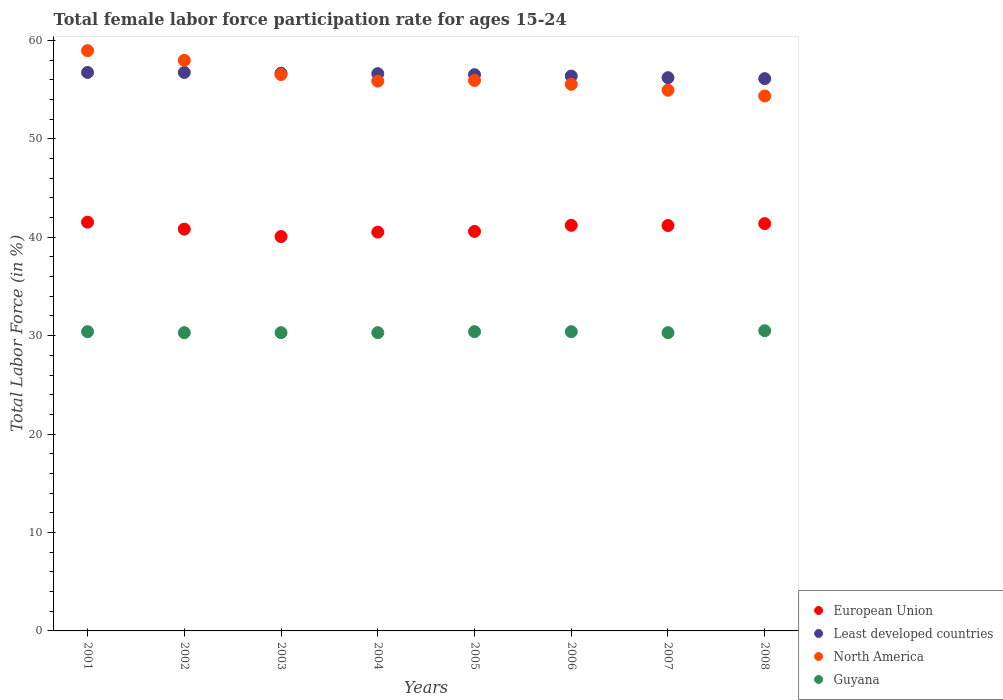How many different coloured dotlines are there?
Offer a terse response. 4. What is the female labor force participation rate in European Union in 2002?
Give a very brief answer. 40.82. Across all years, what is the maximum female labor force participation rate in North America?
Your response must be concise. 58.95. Across all years, what is the minimum female labor force participation rate in Least developed countries?
Keep it short and to the point. 56.11. In which year was the female labor force participation rate in Guyana maximum?
Your response must be concise. 2008. What is the total female labor force participation rate in Guyana in the graph?
Ensure brevity in your answer.  242.9. What is the difference between the female labor force participation rate in Guyana in 2001 and that in 2004?
Your answer should be compact. 0.1. What is the difference between the female labor force participation rate in European Union in 2006 and the female labor force participation rate in North America in 2005?
Provide a short and direct response. -14.72. What is the average female labor force participation rate in Least developed countries per year?
Keep it short and to the point. 56.49. In the year 2002, what is the difference between the female labor force participation rate in North America and female labor force participation rate in European Union?
Offer a terse response. 17.14. What is the ratio of the female labor force participation rate in European Union in 2003 to that in 2005?
Provide a short and direct response. 0.99. Is the difference between the female labor force participation rate in North America in 2001 and 2005 greater than the difference between the female labor force participation rate in European Union in 2001 and 2005?
Provide a succinct answer. Yes. What is the difference between the highest and the second highest female labor force participation rate in North America?
Make the answer very short. 0.99. What is the difference between the highest and the lowest female labor force participation rate in European Union?
Offer a very short reply. 1.46. Is the sum of the female labor force participation rate in European Union in 2004 and 2005 greater than the maximum female labor force participation rate in Guyana across all years?
Provide a short and direct response. Yes. Is it the case that in every year, the sum of the female labor force participation rate in North America and female labor force participation rate in European Union  is greater than the female labor force participation rate in Guyana?
Provide a succinct answer. Yes. Does the female labor force participation rate in Guyana monotonically increase over the years?
Keep it short and to the point. No. How many dotlines are there?
Provide a short and direct response. 4. How many years are there in the graph?
Make the answer very short. 8. Are the values on the major ticks of Y-axis written in scientific E-notation?
Your answer should be compact. No. Does the graph contain any zero values?
Provide a succinct answer. No. Does the graph contain grids?
Keep it short and to the point. No. How many legend labels are there?
Ensure brevity in your answer.  4. How are the legend labels stacked?
Offer a terse response. Vertical. What is the title of the graph?
Your answer should be very brief. Total female labor force participation rate for ages 15-24. Does "Grenada" appear as one of the legend labels in the graph?
Give a very brief answer. No. What is the label or title of the X-axis?
Your response must be concise. Years. What is the Total Labor Force (in %) of European Union in 2001?
Your answer should be compact. 41.53. What is the Total Labor Force (in %) in Least developed countries in 2001?
Provide a short and direct response. 56.74. What is the Total Labor Force (in %) of North America in 2001?
Offer a very short reply. 58.95. What is the Total Labor Force (in %) of Guyana in 2001?
Provide a succinct answer. 30.4. What is the Total Labor Force (in %) of European Union in 2002?
Provide a succinct answer. 40.82. What is the Total Labor Force (in %) of Least developed countries in 2002?
Your answer should be compact. 56.74. What is the Total Labor Force (in %) in North America in 2002?
Make the answer very short. 57.96. What is the Total Labor Force (in %) in Guyana in 2002?
Offer a terse response. 30.3. What is the Total Labor Force (in %) of European Union in 2003?
Offer a terse response. 40.07. What is the Total Labor Force (in %) of Least developed countries in 2003?
Give a very brief answer. 56.67. What is the Total Labor Force (in %) of North America in 2003?
Ensure brevity in your answer.  56.53. What is the Total Labor Force (in %) of Guyana in 2003?
Provide a short and direct response. 30.3. What is the Total Labor Force (in %) in European Union in 2004?
Your answer should be very brief. 40.51. What is the Total Labor Force (in %) of Least developed countries in 2004?
Your response must be concise. 56.61. What is the Total Labor Force (in %) in North America in 2004?
Provide a short and direct response. 55.85. What is the Total Labor Force (in %) in Guyana in 2004?
Your answer should be compact. 30.3. What is the Total Labor Force (in %) of European Union in 2005?
Provide a succinct answer. 40.59. What is the Total Labor Force (in %) of Least developed countries in 2005?
Ensure brevity in your answer.  56.51. What is the Total Labor Force (in %) in North America in 2005?
Your answer should be compact. 55.92. What is the Total Labor Force (in %) of Guyana in 2005?
Give a very brief answer. 30.4. What is the Total Labor Force (in %) of European Union in 2006?
Your response must be concise. 41.2. What is the Total Labor Force (in %) in Least developed countries in 2006?
Your answer should be very brief. 56.37. What is the Total Labor Force (in %) in North America in 2006?
Give a very brief answer. 55.53. What is the Total Labor Force (in %) of Guyana in 2006?
Your answer should be very brief. 30.4. What is the Total Labor Force (in %) in European Union in 2007?
Your answer should be very brief. 41.19. What is the Total Labor Force (in %) in Least developed countries in 2007?
Keep it short and to the point. 56.21. What is the Total Labor Force (in %) in North America in 2007?
Give a very brief answer. 54.93. What is the Total Labor Force (in %) of Guyana in 2007?
Offer a very short reply. 30.3. What is the Total Labor Force (in %) of European Union in 2008?
Ensure brevity in your answer.  41.38. What is the Total Labor Force (in %) of Least developed countries in 2008?
Offer a terse response. 56.11. What is the Total Labor Force (in %) in North America in 2008?
Make the answer very short. 54.35. What is the Total Labor Force (in %) in Guyana in 2008?
Ensure brevity in your answer.  30.5. Across all years, what is the maximum Total Labor Force (in %) of European Union?
Your response must be concise. 41.53. Across all years, what is the maximum Total Labor Force (in %) of Least developed countries?
Provide a short and direct response. 56.74. Across all years, what is the maximum Total Labor Force (in %) of North America?
Provide a succinct answer. 58.95. Across all years, what is the maximum Total Labor Force (in %) in Guyana?
Your response must be concise. 30.5. Across all years, what is the minimum Total Labor Force (in %) of European Union?
Keep it short and to the point. 40.07. Across all years, what is the minimum Total Labor Force (in %) in Least developed countries?
Give a very brief answer. 56.11. Across all years, what is the minimum Total Labor Force (in %) of North America?
Offer a terse response. 54.35. Across all years, what is the minimum Total Labor Force (in %) in Guyana?
Your response must be concise. 30.3. What is the total Total Labor Force (in %) in European Union in the graph?
Provide a short and direct response. 327.29. What is the total Total Labor Force (in %) of Least developed countries in the graph?
Your response must be concise. 451.95. What is the total Total Labor Force (in %) of North America in the graph?
Give a very brief answer. 450.03. What is the total Total Labor Force (in %) in Guyana in the graph?
Offer a terse response. 242.9. What is the difference between the Total Labor Force (in %) in European Union in 2001 and that in 2002?
Provide a short and direct response. 0.71. What is the difference between the Total Labor Force (in %) in Least developed countries in 2001 and that in 2002?
Ensure brevity in your answer.  0. What is the difference between the Total Labor Force (in %) of North America in 2001 and that in 2002?
Keep it short and to the point. 0.99. What is the difference between the Total Labor Force (in %) of Guyana in 2001 and that in 2002?
Give a very brief answer. 0.1. What is the difference between the Total Labor Force (in %) in European Union in 2001 and that in 2003?
Make the answer very short. 1.46. What is the difference between the Total Labor Force (in %) of Least developed countries in 2001 and that in 2003?
Provide a succinct answer. 0.07. What is the difference between the Total Labor Force (in %) in North America in 2001 and that in 2003?
Keep it short and to the point. 2.42. What is the difference between the Total Labor Force (in %) in European Union in 2001 and that in 2004?
Provide a succinct answer. 1.01. What is the difference between the Total Labor Force (in %) of Least developed countries in 2001 and that in 2004?
Make the answer very short. 0.12. What is the difference between the Total Labor Force (in %) in North America in 2001 and that in 2004?
Your answer should be very brief. 3.1. What is the difference between the Total Labor Force (in %) in European Union in 2001 and that in 2005?
Make the answer very short. 0.94. What is the difference between the Total Labor Force (in %) in Least developed countries in 2001 and that in 2005?
Your answer should be very brief. 0.23. What is the difference between the Total Labor Force (in %) in North America in 2001 and that in 2005?
Your response must be concise. 3.03. What is the difference between the Total Labor Force (in %) in European Union in 2001 and that in 2006?
Provide a succinct answer. 0.32. What is the difference between the Total Labor Force (in %) in Least developed countries in 2001 and that in 2006?
Make the answer very short. 0.37. What is the difference between the Total Labor Force (in %) of North America in 2001 and that in 2006?
Offer a very short reply. 3.42. What is the difference between the Total Labor Force (in %) in European Union in 2001 and that in 2007?
Keep it short and to the point. 0.34. What is the difference between the Total Labor Force (in %) of Least developed countries in 2001 and that in 2007?
Provide a short and direct response. 0.53. What is the difference between the Total Labor Force (in %) in North America in 2001 and that in 2007?
Keep it short and to the point. 4.02. What is the difference between the Total Labor Force (in %) in European Union in 2001 and that in 2008?
Provide a short and direct response. 0.15. What is the difference between the Total Labor Force (in %) of Least developed countries in 2001 and that in 2008?
Make the answer very short. 0.63. What is the difference between the Total Labor Force (in %) of North America in 2001 and that in 2008?
Provide a short and direct response. 4.6. What is the difference between the Total Labor Force (in %) in Guyana in 2001 and that in 2008?
Give a very brief answer. -0.1. What is the difference between the Total Labor Force (in %) in European Union in 2002 and that in 2003?
Your answer should be compact. 0.75. What is the difference between the Total Labor Force (in %) in Least developed countries in 2002 and that in 2003?
Ensure brevity in your answer.  0.07. What is the difference between the Total Labor Force (in %) in North America in 2002 and that in 2003?
Keep it short and to the point. 1.43. What is the difference between the Total Labor Force (in %) in European Union in 2002 and that in 2004?
Provide a short and direct response. 0.3. What is the difference between the Total Labor Force (in %) of Least developed countries in 2002 and that in 2004?
Make the answer very short. 0.12. What is the difference between the Total Labor Force (in %) in North America in 2002 and that in 2004?
Provide a short and direct response. 2.11. What is the difference between the Total Labor Force (in %) in Guyana in 2002 and that in 2004?
Provide a succinct answer. 0. What is the difference between the Total Labor Force (in %) in European Union in 2002 and that in 2005?
Offer a very short reply. 0.23. What is the difference between the Total Labor Force (in %) in Least developed countries in 2002 and that in 2005?
Your answer should be very brief. 0.23. What is the difference between the Total Labor Force (in %) in North America in 2002 and that in 2005?
Ensure brevity in your answer.  2.04. What is the difference between the Total Labor Force (in %) in European Union in 2002 and that in 2006?
Keep it short and to the point. -0.38. What is the difference between the Total Labor Force (in %) in Least developed countries in 2002 and that in 2006?
Offer a terse response. 0.37. What is the difference between the Total Labor Force (in %) in North America in 2002 and that in 2006?
Provide a short and direct response. 2.43. What is the difference between the Total Labor Force (in %) of European Union in 2002 and that in 2007?
Offer a terse response. -0.37. What is the difference between the Total Labor Force (in %) of Least developed countries in 2002 and that in 2007?
Your response must be concise. 0.53. What is the difference between the Total Labor Force (in %) in North America in 2002 and that in 2007?
Your response must be concise. 3.03. What is the difference between the Total Labor Force (in %) in Guyana in 2002 and that in 2007?
Give a very brief answer. 0. What is the difference between the Total Labor Force (in %) in European Union in 2002 and that in 2008?
Your answer should be compact. -0.56. What is the difference between the Total Labor Force (in %) of Least developed countries in 2002 and that in 2008?
Keep it short and to the point. 0.63. What is the difference between the Total Labor Force (in %) in North America in 2002 and that in 2008?
Your answer should be very brief. 3.61. What is the difference between the Total Labor Force (in %) of European Union in 2003 and that in 2004?
Your response must be concise. -0.45. What is the difference between the Total Labor Force (in %) of Least developed countries in 2003 and that in 2004?
Provide a short and direct response. 0.05. What is the difference between the Total Labor Force (in %) of North America in 2003 and that in 2004?
Offer a very short reply. 0.67. What is the difference between the Total Labor Force (in %) of Guyana in 2003 and that in 2004?
Your response must be concise. 0. What is the difference between the Total Labor Force (in %) in European Union in 2003 and that in 2005?
Make the answer very short. -0.52. What is the difference between the Total Labor Force (in %) in Least developed countries in 2003 and that in 2005?
Offer a very short reply. 0.15. What is the difference between the Total Labor Force (in %) in North America in 2003 and that in 2005?
Give a very brief answer. 0.6. What is the difference between the Total Labor Force (in %) of Guyana in 2003 and that in 2005?
Give a very brief answer. -0.1. What is the difference between the Total Labor Force (in %) of European Union in 2003 and that in 2006?
Provide a short and direct response. -1.14. What is the difference between the Total Labor Force (in %) of Least developed countries in 2003 and that in 2006?
Provide a short and direct response. 0.29. What is the difference between the Total Labor Force (in %) of North America in 2003 and that in 2006?
Give a very brief answer. 1. What is the difference between the Total Labor Force (in %) in European Union in 2003 and that in 2007?
Your response must be concise. -1.12. What is the difference between the Total Labor Force (in %) of Least developed countries in 2003 and that in 2007?
Ensure brevity in your answer.  0.46. What is the difference between the Total Labor Force (in %) of North America in 2003 and that in 2007?
Offer a terse response. 1.6. What is the difference between the Total Labor Force (in %) of Guyana in 2003 and that in 2007?
Your response must be concise. 0. What is the difference between the Total Labor Force (in %) of European Union in 2003 and that in 2008?
Your response must be concise. -1.31. What is the difference between the Total Labor Force (in %) of Least developed countries in 2003 and that in 2008?
Keep it short and to the point. 0.56. What is the difference between the Total Labor Force (in %) of North America in 2003 and that in 2008?
Provide a short and direct response. 2.18. What is the difference between the Total Labor Force (in %) in Guyana in 2003 and that in 2008?
Offer a terse response. -0.2. What is the difference between the Total Labor Force (in %) in European Union in 2004 and that in 2005?
Your answer should be very brief. -0.07. What is the difference between the Total Labor Force (in %) in Least developed countries in 2004 and that in 2005?
Provide a succinct answer. 0.1. What is the difference between the Total Labor Force (in %) of North America in 2004 and that in 2005?
Your answer should be very brief. -0.07. What is the difference between the Total Labor Force (in %) in Guyana in 2004 and that in 2005?
Give a very brief answer. -0.1. What is the difference between the Total Labor Force (in %) in European Union in 2004 and that in 2006?
Give a very brief answer. -0.69. What is the difference between the Total Labor Force (in %) of Least developed countries in 2004 and that in 2006?
Offer a terse response. 0.24. What is the difference between the Total Labor Force (in %) of North America in 2004 and that in 2006?
Ensure brevity in your answer.  0.32. What is the difference between the Total Labor Force (in %) in European Union in 2004 and that in 2007?
Offer a terse response. -0.67. What is the difference between the Total Labor Force (in %) of Least developed countries in 2004 and that in 2007?
Your response must be concise. 0.41. What is the difference between the Total Labor Force (in %) of North America in 2004 and that in 2007?
Offer a terse response. 0.92. What is the difference between the Total Labor Force (in %) in Guyana in 2004 and that in 2007?
Your answer should be very brief. 0. What is the difference between the Total Labor Force (in %) in European Union in 2004 and that in 2008?
Offer a terse response. -0.87. What is the difference between the Total Labor Force (in %) in Least developed countries in 2004 and that in 2008?
Provide a short and direct response. 0.51. What is the difference between the Total Labor Force (in %) of North America in 2004 and that in 2008?
Ensure brevity in your answer.  1.51. What is the difference between the Total Labor Force (in %) of European Union in 2005 and that in 2006?
Make the answer very short. -0.62. What is the difference between the Total Labor Force (in %) of Least developed countries in 2005 and that in 2006?
Your answer should be compact. 0.14. What is the difference between the Total Labor Force (in %) in North America in 2005 and that in 2006?
Your response must be concise. 0.39. What is the difference between the Total Labor Force (in %) of European Union in 2005 and that in 2007?
Offer a terse response. -0.6. What is the difference between the Total Labor Force (in %) in Least developed countries in 2005 and that in 2007?
Offer a very short reply. 0.31. What is the difference between the Total Labor Force (in %) in North America in 2005 and that in 2007?
Offer a terse response. 0.99. What is the difference between the Total Labor Force (in %) in European Union in 2005 and that in 2008?
Offer a terse response. -0.79. What is the difference between the Total Labor Force (in %) in Least developed countries in 2005 and that in 2008?
Give a very brief answer. 0.4. What is the difference between the Total Labor Force (in %) in North America in 2005 and that in 2008?
Your answer should be very brief. 1.57. What is the difference between the Total Labor Force (in %) in Guyana in 2005 and that in 2008?
Provide a short and direct response. -0.1. What is the difference between the Total Labor Force (in %) in European Union in 2006 and that in 2007?
Your answer should be very brief. 0.02. What is the difference between the Total Labor Force (in %) in Least developed countries in 2006 and that in 2007?
Offer a terse response. 0.17. What is the difference between the Total Labor Force (in %) of North America in 2006 and that in 2007?
Your answer should be very brief. 0.6. What is the difference between the Total Labor Force (in %) in Guyana in 2006 and that in 2007?
Offer a terse response. 0.1. What is the difference between the Total Labor Force (in %) in European Union in 2006 and that in 2008?
Keep it short and to the point. -0.18. What is the difference between the Total Labor Force (in %) in Least developed countries in 2006 and that in 2008?
Your answer should be compact. 0.26. What is the difference between the Total Labor Force (in %) in North America in 2006 and that in 2008?
Provide a succinct answer. 1.18. What is the difference between the Total Labor Force (in %) of European Union in 2007 and that in 2008?
Keep it short and to the point. -0.19. What is the difference between the Total Labor Force (in %) of Least developed countries in 2007 and that in 2008?
Offer a terse response. 0.1. What is the difference between the Total Labor Force (in %) of North America in 2007 and that in 2008?
Provide a succinct answer. 0.58. What is the difference between the Total Labor Force (in %) in Guyana in 2007 and that in 2008?
Your answer should be very brief. -0.2. What is the difference between the Total Labor Force (in %) of European Union in 2001 and the Total Labor Force (in %) of Least developed countries in 2002?
Give a very brief answer. -15.21. What is the difference between the Total Labor Force (in %) in European Union in 2001 and the Total Labor Force (in %) in North America in 2002?
Offer a terse response. -16.44. What is the difference between the Total Labor Force (in %) of European Union in 2001 and the Total Labor Force (in %) of Guyana in 2002?
Your response must be concise. 11.23. What is the difference between the Total Labor Force (in %) in Least developed countries in 2001 and the Total Labor Force (in %) in North America in 2002?
Offer a terse response. -1.23. What is the difference between the Total Labor Force (in %) of Least developed countries in 2001 and the Total Labor Force (in %) of Guyana in 2002?
Offer a very short reply. 26.44. What is the difference between the Total Labor Force (in %) of North America in 2001 and the Total Labor Force (in %) of Guyana in 2002?
Your answer should be very brief. 28.65. What is the difference between the Total Labor Force (in %) in European Union in 2001 and the Total Labor Force (in %) in Least developed countries in 2003?
Keep it short and to the point. -15.14. What is the difference between the Total Labor Force (in %) in European Union in 2001 and the Total Labor Force (in %) in North America in 2003?
Your response must be concise. -15. What is the difference between the Total Labor Force (in %) of European Union in 2001 and the Total Labor Force (in %) of Guyana in 2003?
Provide a succinct answer. 11.23. What is the difference between the Total Labor Force (in %) in Least developed countries in 2001 and the Total Labor Force (in %) in North America in 2003?
Make the answer very short. 0.21. What is the difference between the Total Labor Force (in %) of Least developed countries in 2001 and the Total Labor Force (in %) of Guyana in 2003?
Give a very brief answer. 26.44. What is the difference between the Total Labor Force (in %) in North America in 2001 and the Total Labor Force (in %) in Guyana in 2003?
Ensure brevity in your answer.  28.65. What is the difference between the Total Labor Force (in %) in European Union in 2001 and the Total Labor Force (in %) in Least developed countries in 2004?
Provide a short and direct response. -15.09. What is the difference between the Total Labor Force (in %) of European Union in 2001 and the Total Labor Force (in %) of North America in 2004?
Your response must be concise. -14.33. What is the difference between the Total Labor Force (in %) in European Union in 2001 and the Total Labor Force (in %) in Guyana in 2004?
Your answer should be compact. 11.23. What is the difference between the Total Labor Force (in %) in Least developed countries in 2001 and the Total Labor Force (in %) in North America in 2004?
Your response must be concise. 0.88. What is the difference between the Total Labor Force (in %) in Least developed countries in 2001 and the Total Labor Force (in %) in Guyana in 2004?
Your response must be concise. 26.44. What is the difference between the Total Labor Force (in %) of North America in 2001 and the Total Labor Force (in %) of Guyana in 2004?
Make the answer very short. 28.65. What is the difference between the Total Labor Force (in %) in European Union in 2001 and the Total Labor Force (in %) in Least developed countries in 2005?
Provide a succinct answer. -14.98. What is the difference between the Total Labor Force (in %) in European Union in 2001 and the Total Labor Force (in %) in North America in 2005?
Keep it short and to the point. -14.4. What is the difference between the Total Labor Force (in %) in European Union in 2001 and the Total Labor Force (in %) in Guyana in 2005?
Ensure brevity in your answer.  11.13. What is the difference between the Total Labor Force (in %) of Least developed countries in 2001 and the Total Labor Force (in %) of North America in 2005?
Your answer should be very brief. 0.81. What is the difference between the Total Labor Force (in %) in Least developed countries in 2001 and the Total Labor Force (in %) in Guyana in 2005?
Your answer should be very brief. 26.34. What is the difference between the Total Labor Force (in %) in North America in 2001 and the Total Labor Force (in %) in Guyana in 2005?
Offer a very short reply. 28.55. What is the difference between the Total Labor Force (in %) in European Union in 2001 and the Total Labor Force (in %) in Least developed countries in 2006?
Ensure brevity in your answer.  -14.84. What is the difference between the Total Labor Force (in %) of European Union in 2001 and the Total Labor Force (in %) of North America in 2006?
Provide a short and direct response. -14. What is the difference between the Total Labor Force (in %) in European Union in 2001 and the Total Labor Force (in %) in Guyana in 2006?
Provide a short and direct response. 11.13. What is the difference between the Total Labor Force (in %) of Least developed countries in 2001 and the Total Labor Force (in %) of North America in 2006?
Your response must be concise. 1.21. What is the difference between the Total Labor Force (in %) in Least developed countries in 2001 and the Total Labor Force (in %) in Guyana in 2006?
Your answer should be very brief. 26.34. What is the difference between the Total Labor Force (in %) in North America in 2001 and the Total Labor Force (in %) in Guyana in 2006?
Ensure brevity in your answer.  28.55. What is the difference between the Total Labor Force (in %) in European Union in 2001 and the Total Labor Force (in %) in Least developed countries in 2007?
Provide a succinct answer. -14.68. What is the difference between the Total Labor Force (in %) of European Union in 2001 and the Total Labor Force (in %) of North America in 2007?
Give a very brief answer. -13.4. What is the difference between the Total Labor Force (in %) in European Union in 2001 and the Total Labor Force (in %) in Guyana in 2007?
Give a very brief answer. 11.23. What is the difference between the Total Labor Force (in %) in Least developed countries in 2001 and the Total Labor Force (in %) in North America in 2007?
Keep it short and to the point. 1.81. What is the difference between the Total Labor Force (in %) in Least developed countries in 2001 and the Total Labor Force (in %) in Guyana in 2007?
Provide a succinct answer. 26.44. What is the difference between the Total Labor Force (in %) of North America in 2001 and the Total Labor Force (in %) of Guyana in 2007?
Offer a terse response. 28.65. What is the difference between the Total Labor Force (in %) in European Union in 2001 and the Total Labor Force (in %) in Least developed countries in 2008?
Keep it short and to the point. -14.58. What is the difference between the Total Labor Force (in %) of European Union in 2001 and the Total Labor Force (in %) of North America in 2008?
Keep it short and to the point. -12.82. What is the difference between the Total Labor Force (in %) in European Union in 2001 and the Total Labor Force (in %) in Guyana in 2008?
Your response must be concise. 11.03. What is the difference between the Total Labor Force (in %) of Least developed countries in 2001 and the Total Labor Force (in %) of North America in 2008?
Keep it short and to the point. 2.39. What is the difference between the Total Labor Force (in %) of Least developed countries in 2001 and the Total Labor Force (in %) of Guyana in 2008?
Offer a terse response. 26.24. What is the difference between the Total Labor Force (in %) of North America in 2001 and the Total Labor Force (in %) of Guyana in 2008?
Your answer should be very brief. 28.45. What is the difference between the Total Labor Force (in %) in European Union in 2002 and the Total Labor Force (in %) in Least developed countries in 2003?
Ensure brevity in your answer.  -15.85. What is the difference between the Total Labor Force (in %) in European Union in 2002 and the Total Labor Force (in %) in North America in 2003?
Offer a very short reply. -15.71. What is the difference between the Total Labor Force (in %) in European Union in 2002 and the Total Labor Force (in %) in Guyana in 2003?
Ensure brevity in your answer.  10.52. What is the difference between the Total Labor Force (in %) of Least developed countries in 2002 and the Total Labor Force (in %) of North America in 2003?
Keep it short and to the point. 0.21. What is the difference between the Total Labor Force (in %) in Least developed countries in 2002 and the Total Labor Force (in %) in Guyana in 2003?
Make the answer very short. 26.44. What is the difference between the Total Labor Force (in %) in North America in 2002 and the Total Labor Force (in %) in Guyana in 2003?
Ensure brevity in your answer.  27.66. What is the difference between the Total Labor Force (in %) of European Union in 2002 and the Total Labor Force (in %) of Least developed countries in 2004?
Make the answer very short. -15.8. What is the difference between the Total Labor Force (in %) of European Union in 2002 and the Total Labor Force (in %) of North America in 2004?
Your response must be concise. -15.04. What is the difference between the Total Labor Force (in %) of European Union in 2002 and the Total Labor Force (in %) of Guyana in 2004?
Your answer should be very brief. 10.52. What is the difference between the Total Labor Force (in %) in Least developed countries in 2002 and the Total Labor Force (in %) in North America in 2004?
Provide a short and direct response. 0.88. What is the difference between the Total Labor Force (in %) in Least developed countries in 2002 and the Total Labor Force (in %) in Guyana in 2004?
Your answer should be very brief. 26.44. What is the difference between the Total Labor Force (in %) in North America in 2002 and the Total Labor Force (in %) in Guyana in 2004?
Provide a succinct answer. 27.66. What is the difference between the Total Labor Force (in %) of European Union in 2002 and the Total Labor Force (in %) of Least developed countries in 2005?
Your answer should be compact. -15.69. What is the difference between the Total Labor Force (in %) of European Union in 2002 and the Total Labor Force (in %) of North America in 2005?
Your answer should be very brief. -15.11. What is the difference between the Total Labor Force (in %) of European Union in 2002 and the Total Labor Force (in %) of Guyana in 2005?
Offer a very short reply. 10.42. What is the difference between the Total Labor Force (in %) of Least developed countries in 2002 and the Total Labor Force (in %) of North America in 2005?
Ensure brevity in your answer.  0.81. What is the difference between the Total Labor Force (in %) of Least developed countries in 2002 and the Total Labor Force (in %) of Guyana in 2005?
Provide a succinct answer. 26.34. What is the difference between the Total Labor Force (in %) in North America in 2002 and the Total Labor Force (in %) in Guyana in 2005?
Provide a short and direct response. 27.56. What is the difference between the Total Labor Force (in %) of European Union in 2002 and the Total Labor Force (in %) of Least developed countries in 2006?
Offer a very short reply. -15.55. What is the difference between the Total Labor Force (in %) in European Union in 2002 and the Total Labor Force (in %) in North America in 2006?
Your answer should be very brief. -14.71. What is the difference between the Total Labor Force (in %) of European Union in 2002 and the Total Labor Force (in %) of Guyana in 2006?
Make the answer very short. 10.42. What is the difference between the Total Labor Force (in %) of Least developed countries in 2002 and the Total Labor Force (in %) of North America in 2006?
Provide a short and direct response. 1.21. What is the difference between the Total Labor Force (in %) in Least developed countries in 2002 and the Total Labor Force (in %) in Guyana in 2006?
Offer a very short reply. 26.34. What is the difference between the Total Labor Force (in %) of North America in 2002 and the Total Labor Force (in %) of Guyana in 2006?
Make the answer very short. 27.56. What is the difference between the Total Labor Force (in %) in European Union in 2002 and the Total Labor Force (in %) in Least developed countries in 2007?
Your answer should be very brief. -15.39. What is the difference between the Total Labor Force (in %) in European Union in 2002 and the Total Labor Force (in %) in North America in 2007?
Your response must be concise. -14.11. What is the difference between the Total Labor Force (in %) of European Union in 2002 and the Total Labor Force (in %) of Guyana in 2007?
Offer a very short reply. 10.52. What is the difference between the Total Labor Force (in %) of Least developed countries in 2002 and the Total Labor Force (in %) of North America in 2007?
Give a very brief answer. 1.81. What is the difference between the Total Labor Force (in %) of Least developed countries in 2002 and the Total Labor Force (in %) of Guyana in 2007?
Offer a terse response. 26.44. What is the difference between the Total Labor Force (in %) in North America in 2002 and the Total Labor Force (in %) in Guyana in 2007?
Keep it short and to the point. 27.66. What is the difference between the Total Labor Force (in %) of European Union in 2002 and the Total Labor Force (in %) of Least developed countries in 2008?
Give a very brief answer. -15.29. What is the difference between the Total Labor Force (in %) of European Union in 2002 and the Total Labor Force (in %) of North America in 2008?
Keep it short and to the point. -13.53. What is the difference between the Total Labor Force (in %) in European Union in 2002 and the Total Labor Force (in %) in Guyana in 2008?
Your answer should be compact. 10.32. What is the difference between the Total Labor Force (in %) in Least developed countries in 2002 and the Total Labor Force (in %) in North America in 2008?
Give a very brief answer. 2.39. What is the difference between the Total Labor Force (in %) in Least developed countries in 2002 and the Total Labor Force (in %) in Guyana in 2008?
Offer a very short reply. 26.24. What is the difference between the Total Labor Force (in %) of North America in 2002 and the Total Labor Force (in %) of Guyana in 2008?
Your answer should be very brief. 27.46. What is the difference between the Total Labor Force (in %) of European Union in 2003 and the Total Labor Force (in %) of Least developed countries in 2004?
Provide a short and direct response. -16.55. What is the difference between the Total Labor Force (in %) of European Union in 2003 and the Total Labor Force (in %) of North America in 2004?
Offer a very short reply. -15.79. What is the difference between the Total Labor Force (in %) of European Union in 2003 and the Total Labor Force (in %) of Guyana in 2004?
Give a very brief answer. 9.77. What is the difference between the Total Labor Force (in %) in Least developed countries in 2003 and the Total Labor Force (in %) in North America in 2004?
Provide a succinct answer. 0.81. What is the difference between the Total Labor Force (in %) in Least developed countries in 2003 and the Total Labor Force (in %) in Guyana in 2004?
Give a very brief answer. 26.37. What is the difference between the Total Labor Force (in %) in North America in 2003 and the Total Labor Force (in %) in Guyana in 2004?
Your answer should be very brief. 26.23. What is the difference between the Total Labor Force (in %) in European Union in 2003 and the Total Labor Force (in %) in Least developed countries in 2005?
Provide a succinct answer. -16.44. What is the difference between the Total Labor Force (in %) in European Union in 2003 and the Total Labor Force (in %) in North America in 2005?
Offer a very short reply. -15.86. What is the difference between the Total Labor Force (in %) in European Union in 2003 and the Total Labor Force (in %) in Guyana in 2005?
Your response must be concise. 9.67. What is the difference between the Total Labor Force (in %) of Least developed countries in 2003 and the Total Labor Force (in %) of North America in 2005?
Make the answer very short. 0.74. What is the difference between the Total Labor Force (in %) in Least developed countries in 2003 and the Total Labor Force (in %) in Guyana in 2005?
Your answer should be very brief. 26.27. What is the difference between the Total Labor Force (in %) in North America in 2003 and the Total Labor Force (in %) in Guyana in 2005?
Provide a succinct answer. 26.13. What is the difference between the Total Labor Force (in %) of European Union in 2003 and the Total Labor Force (in %) of Least developed countries in 2006?
Keep it short and to the point. -16.3. What is the difference between the Total Labor Force (in %) in European Union in 2003 and the Total Labor Force (in %) in North America in 2006?
Offer a very short reply. -15.46. What is the difference between the Total Labor Force (in %) in European Union in 2003 and the Total Labor Force (in %) in Guyana in 2006?
Make the answer very short. 9.67. What is the difference between the Total Labor Force (in %) in Least developed countries in 2003 and the Total Labor Force (in %) in North America in 2006?
Provide a short and direct response. 1.13. What is the difference between the Total Labor Force (in %) of Least developed countries in 2003 and the Total Labor Force (in %) of Guyana in 2006?
Ensure brevity in your answer.  26.27. What is the difference between the Total Labor Force (in %) in North America in 2003 and the Total Labor Force (in %) in Guyana in 2006?
Provide a short and direct response. 26.13. What is the difference between the Total Labor Force (in %) in European Union in 2003 and the Total Labor Force (in %) in Least developed countries in 2007?
Your answer should be very brief. -16.14. What is the difference between the Total Labor Force (in %) of European Union in 2003 and the Total Labor Force (in %) of North America in 2007?
Provide a succinct answer. -14.86. What is the difference between the Total Labor Force (in %) in European Union in 2003 and the Total Labor Force (in %) in Guyana in 2007?
Keep it short and to the point. 9.77. What is the difference between the Total Labor Force (in %) in Least developed countries in 2003 and the Total Labor Force (in %) in North America in 2007?
Provide a short and direct response. 1.73. What is the difference between the Total Labor Force (in %) of Least developed countries in 2003 and the Total Labor Force (in %) of Guyana in 2007?
Make the answer very short. 26.37. What is the difference between the Total Labor Force (in %) in North America in 2003 and the Total Labor Force (in %) in Guyana in 2007?
Your answer should be very brief. 26.23. What is the difference between the Total Labor Force (in %) in European Union in 2003 and the Total Labor Force (in %) in Least developed countries in 2008?
Your answer should be very brief. -16.04. What is the difference between the Total Labor Force (in %) in European Union in 2003 and the Total Labor Force (in %) in North America in 2008?
Your answer should be compact. -14.28. What is the difference between the Total Labor Force (in %) in European Union in 2003 and the Total Labor Force (in %) in Guyana in 2008?
Keep it short and to the point. 9.57. What is the difference between the Total Labor Force (in %) of Least developed countries in 2003 and the Total Labor Force (in %) of North America in 2008?
Your answer should be compact. 2.32. What is the difference between the Total Labor Force (in %) of Least developed countries in 2003 and the Total Labor Force (in %) of Guyana in 2008?
Provide a succinct answer. 26.17. What is the difference between the Total Labor Force (in %) in North America in 2003 and the Total Labor Force (in %) in Guyana in 2008?
Provide a short and direct response. 26.03. What is the difference between the Total Labor Force (in %) in European Union in 2004 and the Total Labor Force (in %) in Least developed countries in 2005?
Offer a terse response. -16. What is the difference between the Total Labor Force (in %) in European Union in 2004 and the Total Labor Force (in %) in North America in 2005?
Ensure brevity in your answer.  -15.41. What is the difference between the Total Labor Force (in %) in European Union in 2004 and the Total Labor Force (in %) in Guyana in 2005?
Your answer should be very brief. 10.11. What is the difference between the Total Labor Force (in %) of Least developed countries in 2004 and the Total Labor Force (in %) of North America in 2005?
Your answer should be very brief. 0.69. What is the difference between the Total Labor Force (in %) in Least developed countries in 2004 and the Total Labor Force (in %) in Guyana in 2005?
Keep it short and to the point. 26.21. What is the difference between the Total Labor Force (in %) of North America in 2004 and the Total Labor Force (in %) of Guyana in 2005?
Your response must be concise. 25.45. What is the difference between the Total Labor Force (in %) of European Union in 2004 and the Total Labor Force (in %) of Least developed countries in 2006?
Keep it short and to the point. -15.86. What is the difference between the Total Labor Force (in %) in European Union in 2004 and the Total Labor Force (in %) in North America in 2006?
Offer a very short reply. -15.02. What is the difference between the Total Labor Force (in %) of European Union in 2004 and the Total Labor Force (in %) of Guyana in 2006?
Make the answer very short. 10.11. What is the difference between the Total Labor Force (in %) of Least developed countries in 2004 and the Total Labor Force (in %) of North America in 2006?
Offer a very short reply. 1.08. What is the difference between the Total Labor Force (in %) in Least developed countries in 2004 and the Total Labor Force (in %) in Guyana in 2006?
Offer a very short reply. 26.21. What is the difference between the Total Labor Force (in %) in North America in 2004 and the Total Labor Force (in %) in Guyana in 2006?
Give a very brief answer. 25.45. What is the difference between the Total Labor Force (in %) of European Union in 2004 and the Total Labor Force (in %) of Least developed countries in 2007?
Provide a short and direct response. -15.69. What is the difference between the Total Labor Force (in %) of European Union in 2004 and the Total Labor Force (in %) of North America in 2007?
Your response must be concise. -14.42. What is the difference between the Total Labor Force (in %) of European Union in 2004 and the Total Labor Force (in %) of Guyana in 2007?
Provide a succinct answer. 10.21. What is the difference between the Total Labor Force (in %) of Least developed countries in 2004 and the Total Labor Force (in %) of North America in 2007?
Your response must be concise. 1.68. What is the difference between the Total Labor Force (in %) in Least developed countries in 2004 and the Total Labor Force (in %) in Guyana in 2007?
Provide a short and direct response. 26.31. What is the difference between the Total Labor Force (in %) in North America in 2004 and the Total Labor Force (in %) in Guyana in 2007?
Offer a very short reply. 25.55. What is the difference between the Total Labor Force (in %) of European Union in 2004 and the Total Labor Force (in %) of Least developed countries in 2008?
Your response must be concise. -15.59. What is the difference between the Total Labor Force (in %) of European Union in 2004 and the Total Labor Force (in %) of North America in 2008?
Provide a succinct answer. -13.83. What is the difference between the Total Labor Force (in %) in European Union in 2004 and the Total Labor Force (in %) in Guyana in 2008?
Your answer should be very brief. 10.01. What is the difference between the Total Labor Force (in %) of Least developed countries in 2004 and the Total Labor Force (in %) of North America in 2008?
Your answer should be very brief. 2.27. What is the difference between the Total Labor Force (in %) in Least developed countries in 2004 and the Total Labor Force (in %) in Guyana in 2008?
Keep it short and to the point. 26.11. What is the difference between the Total Labor Force (in %) of North America in 2004 and the Total Labor Force (in %) of Guyana in 2008?
Your answer should be very brief. 25.35. What is the difference between the Total Labor Force (in %) in European Union in 2005 and the Total Labor Force (in %) in Least developed countries in 2006?
Your answer should be very brief. -15.78. What is the difference between the Total Labor Force (in %) of European Union in 2005 and the Total Labor Force (in %) of North America in 2006?
Your response must be concise. -14.94. What is the difference between the Total Labor Force (in %) in European Union in 2005 and the Total Labor Force (in %) in Guyana in 2006?
Offer a terse response. 10.19. What is the difference between the Total Labor Force (in %) of Least developed countries in 2005 and the Total Labor Force (in %) of North America in 2006?
Ensure brevity in your answer.  0.98. What is the difference between the Total Labor Force (in %) of Least developed countries in 2005 and the Total Labor Force (in %) of Guyana in 2006?
Provide a succinct answer. 26.11. What is the difference between the Total Labor Force (in %) in North America in 2005 and the Total Labor Force (in %) in Guyana in 2006?
Provide a succinct answer. 25.52. What is the difference between the Total Labor Force (in %) in European Union in 2005 and the Total Labor Force (in %) in Least developed countries in 2007?
Provide a succinct answer. -15.62. What is the difference between the Total Labor Force (in %) of European Union in 2005 and the Total Labor Force (in %) of North America in 2007?
Provide a succinct answer. -14.34. What is the difference between the Total Labor Force (in %) in European Union in 2005 and the Total Labor Force (in %) in Guyana in 2007?
Provide a succinct answer. 10.29. What is the difference between the Total Labor Force (in %) of Least developed countries in 2005 and the Total Labor Force (in %) of North America in 2007?
Your answer should be very brief. 1.58. What is the difference between the Total Labor Force (in %) of Least developed countries in 2005 and the Total Labor Force (in %) of Guyana in 2007?
Keep it short and to the point. 26.21. What is the difference between the Total Labor Force (in %) in North America in 2005 and the Total Labor Force (in %) in Guyana in 2007?
Offer a terse response. 25.62. What is the difference between the Total Labor Force (in %) in European Union in 2005 and the Total Labor Force (in %) in Least developed countries in 2008?
Offer a very short reply. -15.52. What is the difference between the Total Labor Force (in %) in European Union in 2005 and the Total Labor Force (in %) in North America in 2008?
Your answer should be very brief. -13.76. What is the difference between the Total Labor Force (in %) in European Union in 2005 and the Total Labor Force (in %) in Guyana in 2008?
Your answer should be very brief. 10.09. What is the difference between the Total Labor Force (in %) in Least developed countries in 2005 and the Total Labor Force (in %) in North America in 2008?
Provide a short and direct response. 2.16. What is the difference between the Total Labor Force (in %) in Least developed countries in 2005 and the Total Labor Force (in %) in Guyana in 2008?
Provide a succinct answer. 26.01. What is the difference between the Total Labor Force (in %) in North America in 2005 and the Total Labor Force (in %) in Guyana in 2008?
Ensure brevity in your answer.  25.42. What is the difference between the Total Labor Force (in %) of European Union in 2006 and the Total Labor Force (in %) of Least developed countries in 2007?
Provide a short and direct response. -15. What is the difference between the Total Labor Force (in %) of European Union in 2006 and the Total Labor Force (in %) of North America in 2007?
Ensure brevity in your answer.  -13.73. What is the difference between the Total Labor Force (in %) of European Union in 2006 and the Total Labor Force (in %) of Guyana in 2007?
Your answer should be compact. 10.9. What is the difference between the Total Labor Force (in %) in Least developed countries in 2006 and the Total Labor Force (in %) in North America in 2007?
Your answer should be compact. 1.44. What is the difference between the Total Labor Force (in %) in Least developed countries in 2006 and the Total Labor Force (in %) in Guyana in 2007?
Provide a short and direct response. 26.07. What is the difference between the Total Labor Force (in %) of North America in 2006 and the Total Labor Force (in %) of Guyana in 2007?
Your answer should be very brief. 25.23. What is the difference between the Total Labor Force (in %) of European Union in 2006 and the Total Labor Force (in %) of Least developed countries in 2008?
Make the answer very short. -14.91. What is the difference between the Total Labor Force (in %) of European Union in 2006 and the Total Labor Force (in %) of North America in 2008?
Provide a succinct answer. -13.15. What is the difference between the Total Labor Force (in %) in European Union in 2006 and the Total Labor Force (in %) in Guyana in 2008?
Give a very brief answer. 10.7. What is the difference between the Total Labor Force (in %) of Least developed countries in 2006 and the Total Labor Force (in %) of North America in 2008?
Ensure brevity in your answer.  2.02. What is the difference between the Total Labor Force (in %) in Least developed countries in 2006 and the Total Labor Force (in %) in Guyana in 2008?
Keep it short and to the point. 25.87. What is the difference between the Total Labor Force (in %) in North America in 2006 and the Total Labor Force (in %) in Guyana in 2008?
Keep it short and to the point. 25.03. What is the difference between the Total Labor Force (in %) of European Union in 2007 and the Total Labor Force (in %) of Least developed countries in 2008?
Your answer should be compact. -14.92. What is the difference between the Total Labor Force (in %) in European Union in 2007 and the Total Labor Force (in %) in North America in 2008?
Provide a succinct answer. -13.16. What is the difference between the Total Labor Force (in %) in European Union in 2007 and the Total Labor Force (in %) in Guyana in 2008?
Give a very brief answer. 10.69. What is the difference between the Total Labor Force (in %) of Least developed countries in 2007 and the Total Labor Force (in %) of North America in 2008?
Provide a short and direct response. 1.86. What is the difference between the Total Labor Force (in %) in Least developed countries in 2007 and the Total Labor Force (in %) in Guyana in 2008?
Provide a succinct answer. 25.71. What is the difference between the Total Labor Force (in %) in North America in 2007 and the Total Labor Force (in %) in Guyana in 2008?
Make the answer very short. 24.43. What is the average Total Labor Force (in %) in European Union per year?
Provide a short and direct response. 40.91. What is the average Total Labor Force (in %) in Least developed countries per year?
Make the answer very short. 56.49. What is the average Total Labor Force (in %) in North America per year?
Your answer should be very brief. 56.25. What is the average Total Labor Force (in %) in Guyana per year?
Offer a very short reply. 30.36. In the year 2001, what is the difference between the Total Labor Force (in %) in European Union and Total Labor Force (in %) in Least developed countries?
Keep it short and to the point. -15.21. In the year 2001, what is the difference between the Total Labor Force (in %) of European Union and Total Labor Force (in %) of North America?
Offer a very short reply. -17.42. In the year 2001, what is the difference between the Total Labor Force (in %) of European Union and Total Labor Force (in %) of Guyana?
Keep it short and to the point. 11.13. In the year 2001, what is the difference between the Total Labor Force (in %) in Least developed countries and Total Labor Force (in %) in North America?
Provide a succinct answer. -2.21. In the year 2001, what is the difference between the Total Labor Force (in %) of Least developed countries and Total Labor Force (in %) of Guyana?
Provide a short and direct response. 26.34. In the year 2001, what is the difference between the Total Labor Force (in %) of North America and Total Labor Force (in %) of Guyana?
Give a very brief answer. 28.55. In the year 2002, what is the difference between the Total Labor Force (in %) in European Union and Total Labor Force (in %) in Least developed countries?
Your answer should be compact. -15.92. In the year 2002, what is the difference between the Total Labor Force (in %) in European Union and Total Labor Force (in %) in North America?
Your answer should be very brief. -17.14. In the year 2002, what is the difference between the Total Labor Force (in %) of European Union and Total Labor Force (in %) of Guyana?
Provide a succinct answer. 10.52. In the year 2002, what is the difference between the Total Labor Force (in %) of Least developed countries and Total Labor Force (in %) of North America?
Provide a succinct answer. -1.23. In the year 2002, what is the difference between the Total Labor Force (in %) in Least developed countries and Total Labor Force (in %) in Guyana?
Your answer should be very brief. 26.44. In the year 2002, what is the difference between the Total Labor Force (in %) in North America and Total Labor Force (in %) in Guyana?
Keep it short and to the point. 27.66. In the year 2003, what is the difference between the Total Labor Force (in %) of European Union and Total Labor Force (in %) of Least developed countries?
Provide a short and direct response. -16.6. In the year 2003, what is the difference between the Total Labor Force (in %) in European Union and Total Labor Force (in %) in North America?
Provide a succinct answer. -16.46. In the year 2003, what is the difference between the Total Labor Force (in %) of European Union and Total Labor Force (in %) of Guyana?
Offer a very short reply. 9.77. In the year 2003, what is the difference between the Total Labor Force (in %) in Least developed countries and Total Labor Force (in %) in North America?
Offer a terse response. 0.14. In the year 2003, what is the difference between the Total Labor Force (in %) of Least developed countries and Total Labor Force (in %) of Guyana?
Your answer should be very brief. 26.37. In the year 2003, what is the difference between the Total Labor Force (in %) in North America and Total Labor Force (in %) in Guyana?
Your answer should be compact. 26.23. In the year 2004, what is the difference between the Total Labor Force (in %) of European Union and Total Labor Force (in %) of Least developed countries?
Make the answer very short. -16.1. In the year 2004, what is the difference between the Total Labor Force (in %) in European Union and Total Labor Force (in %) in North America?
Your answer should be compact. -15.34. In the year 2004, what is the difference between the Total Labor Force (in %) of European Union and Total Labor Force (in %) of Guyana?
Ensure brevity in your answer.  10.21. In the year 2004, what is the difference between the Total Labor Force (in %) of Least developed countries and Total Labor Force (in %) of North America?
Offer a very short reply. 0.76. In the year 2004, what is the difference between the Total Labor Force (in %) of Least developed countries and Total Labor Force (in %) of Guyana?
Your answer should be very brief. 26.31. In the year 2004, what is the difference between the Total Labor Force (in %) of North America and Total Labor Force (in %) of Guyana?
Your response must be concise. 25.55. In the year 2005, what is the difference between the Total Labor Force (in %) of European Union and Total Labor Force (in %) of Least developed countries?
Offer a very short reply. -15.92. In the year 2005, what is the difference between the Total Labor Force (in %) in European Union and Total Labor Force (in %) in North America?
Provide a short and direct response. -15.34. In the year 2005, what is the difference between the Total Labor Force (in %) in European Union and Total Labor Force (in %) in Guyana?
Your response must be concise. 10.19. In the year 2005, what is the difference between the Total Labor Force (in %) of Least developed countries and Total Labor Force (in %) of North America?
Keep it short and to the point. 0.59. In the year 2005, what is the difference between the Total Labor Force (in %) of Least developed countries and Total Labor Force (in %) of Guyana?
Give a very brief answer. 26.11. In the year 2005, what is the difference between the Total Labor Force (in %) in North America and Total Labor Force (in %) in Guyana?
Your answer should be compact. 25.52. In the year 2006, what is the difference between the Total Labor Force (in %) in European Union and Total Labor Force (in %) in Least developed countries?
Give a very brief answer. -15.17. In the year 2006, what is the difference between the Total Labor Force (in %) in European Union and Total Labor Force (in %) in North America?
Make the answer very short. -14.33. In the year 2006, what is the difference between the Total Labor Force (in %) in European Union and Total Labor Force (in %) in Guyana?
Keep it short and to the point. 10.8. In the year 2006, what is the difference between the Total Labor Force (in %) in Least developed countries and Total Labor Force (in %) in North America?
Your answer should be compact. 0.84. In the year 2006, what is the difference between the Total Labor Force (in %) of Least developed countries and Total Labor Force (in %) of Guyana?
Offer a terse response. 25.97. In the year 2006, what is the difference between the Total Labor Force (in %) in North America and Total Labor Force (in %) in Guyana?
Offer a very short reply. 25.13. In the year 2007, what is the difference between the Total Labor Force (in %) in European Union and Total Labor Force (in %) in Least developed countries?
Provide a succinct answer. -15.02. In the year 2007, what is the difference between the Total Labor Force (in %) in European Union and Total Labor Force (in %) in North America?
Offer a terse response. -13.74. In the year 2007, what is the difference between the Total Labor Force (in %) of European Union and Total Labor Force (in %) of Guyana?
Provide a succinct answer. 10.89. In the year 2007, what is the difference between the Total Labor Force (in %) of Least developed countries and Total Labor Force (in %) of North America?
Your response must be concise. 1.27. In the year 2007, what is the difference between the Total Labor Force (in %) of Least developed countries and Total Labor Force (in %) of Guyana?
Ensure brevity in your answer.  25.91. In the year 2007, what is the difference between the Total Labor Force (in %) of North America and Total Labor Force (in %) of Guyana?
Your response must be concise. 24.63. In the year 2008, what is the difference between the Total Labor Force (in %) of European Union and Total Labor Force (in %) of Least developed countries?
Give a very brief answer. -14.73. In the year 2008, what is the difference between the Total Labor Force (in %) of European Union and Total Labor Force (in %) of North America?
Offer a terse response. -12.97. In the year 2008, what is the difference between the Total Labor Force (in %) of European Union and Total Labor Force (in %) of Guyana?
Your answer should be compact. 10.88. In the year 2008, what is the difference between the Total Labor Force (in %) of Least developed countries and Total Labor Force (in %) of North America?
Your answer should be compact. 1.76. In the year 2008, what is the difference between the Total Labor Force (in %) of Least developed countries and Total Labor Force (in %) of Guyana?
Ensure brevity in your answer.  25.61. In the year 2008, what is the difference between the Total Labor Force (in %) in North America and Total Labor Force (in %) in Guyana?
Ensure brevity in your answer.  23.85. What is the ratio of the Total Labor Force (in %) in European Union in 2001 to that in 2002?
Your answer should be compact. 1.02. What is the ratio of the Total Labor Force (in %) of European Union in 2001 to that in 2003?
Your response must be concise. 1.04. What is the ratio of the Total Labor Force (in %) of Least developed countries in 2001 to that in 2003?
Your answer should be compact. 1. What is the ratio of the Total Labor Force (in %) of North America in 2001 to that in 2003?
Make the answer very short. 1.04. What is the ratio of the Total Labor Force (in %) in Guyana in 2001 to that in 2003?
Your answer should be very brief. 1. What is the ratio of the Total Labor Force (in %) of Least developed countries in 2001 to that in 2004?
Make the answer very short. 1. What is the ratio of the Total Labor Force (in %) in North America in 2001 to that in 2004?
Offer a very short reply. 1.06. What is the ratio of the Total Labor Force (in %) in Guyana in 2001 to that in 2004?
Give a very brief answer. 1. What is the ratio of the Total Labor Force (in %) in European Union in 2001 to that in 2005?
Provide a succinct answer. 1.02. What is the ratio of the Total Labor Force (in %) in Least developed countries in 2001 to that in 2005?
Ensure brevity in your answer.  1. What is the ratio of the Total Labor Force (in %) in North America in 2001 to that in 2005?
Your answer should be compact. 1.05. What is the ratio of the Total Labor Force (in %) in European Union in 2001 to that in 2006?
Your response must be concise. 1.01. What is the ratio of the Total Labor Force (in %) in Least developed countries in 2001 to that in 2006?
Your response must be concise. 1.01. What is the ratio of the Total Labor Force (in %) in North America in 2001 to that in 2006?
Offer a very short reply. 1.06. What is the ratio of the Total Labor Force (in %) of European Union in 2001 to that in 2007?
Your answer should be very brief. 1.01. What is the ratio of the Total Labor Force (in %) of Least developed countries in 2001 to that in 2007?
Offer a terse response. 1.01. What is the ratio of the Total Labor Force (in %) of North America in 2001 to that in 2007?
Ensure brevity in your answer.  1.07. What is the ratio of the Total Labor Force (in %) of Least developed countries in 2001 to that in 2008?
Offer a terse response. 1.01. What is the ratio of the Total Labor Force (in %) of North America in 2001 to that in 2008?
Offer a terse response. 1.08. What is the ratio of the Total Labor Force (in %) in Guyana in 2001 to that in 2008?
Your response must be concise. 1. What is the ratio of the Total Labor Force (in %) in European Union in 2002 to that in 2003?
Your answer should be very brief. 1.02. What is the ratio of the Total Labor Force (in %) in North America in 2002 to that in 2003?
Your answer should be compact. 1.03. What is the ratio of the Total Labor Force (in %) in Guyana in 2002 to that in 2003?
Provide a succinct answer. 1. What is the ratio of the Total Labor Force (in %) in European Union in 2002 to that in 2004?
Make the answer very short. 1.01. What is the ratio of the Total Labor Force (in %) of North America in 2002 to that in 2004?
Offer a terse response. 1.04. What is the ratio of the Total Labor Force (in %) in Guyana in 2002 to that in 2004?
Keep it short and to the point. 1. What is the ratio of the Total Labor Force (in %) in European Union in 2002 to that in 2005?
Provide a succinct answer. 1.01. What is the ratio of the Total Labor Force (in %) of Least developed countries in 2002 to that in 2005?
Your response must be concise. 1. What is the ratio of the Total Labor Force (in %) of North America in 2002 to that in 2005?
Your response must be concise. 1.04. What is the ratio of the Total Labor Force (in %) in Guyana in 2002 to that in 2005?
Your answer should be compact. 1. What is the ratio of the Total Labor Force (in %) in European Union in 2002 to that in 2006?
Make the answer very short. 0.99. What is the ratio of the Total Labor Force (in %) in Least developed countries in 2002 to that in 2006?
Make the answer very short. 1.01. What is the ratio of the Total Labor Force (in %) in North America in 2002 to that in 2006?
Make the answer very short. 1.04. What is the ratio of the Total Labor Force (in %) of Guyana in 2002 to that in 2006?
Give a very brief answer. 1. What is the ratio of the Total Labor Force (in %) of Least developed countries in 2002 to that in 2007?
Give a very brief answer. 1.01. What is the ratio of the Total Labor Force (in %) in North America in 2002 to that in 2007?
Make the answer very short. 1.06. What is the ratio of the Total Labor Force (in %) in Guyana in 2002 to that in 2007?
Make the answer very short. 1. What is the ratio of the Total Labor Force (in %) of European Union in 2002 to that in 2008?
Your response must be concise. 0.99. What is the ratio of the Total Labor Force (in %) in Least developed countries in 2002 to that in 2008?
Offer a very short reply. 1.01. What is the ratio of the Total Labor Force (in %) in North America in 2002 to that in 2008?
Make the answer very short. 1.07. What is the ratio of the Total Labor Force (in %) in Least developed countries in 2003 to that in 2004?
Offer a very short reply. 1. What is the ratio of the Total Labor Force (in %) in North America in 2003 to that in 2004?
Provide a succinct answer. 1.01. What is the ratio of the Total Labor Force (in %) of Guyana in 2003 to that in 2004?
Provide a succinct answer. 1. What is the ratio of the Total Labor Force (in %) of European Union in 2003 to that in 2005?
Your answer should be compact. 0.99. What is the ratio of the Total Labor Force (in %) in Least developed countries in 2003 to that in 2005?
Provide a short and direct response. 1. What is the ratio of the Total Labor Force (in %) of North America in 2003 to that in 2005?
Your answer should be compact. 1.01. What is the ratio of the Total Labor Force (in %) of Guyana in 2003 to that in 2005?
Provide a short and direct response. 1. What is the ratio of the Total Labor Force (in %) in European Union in 2003 to that in 2006?
Your answer should be very brief. 0.97. What is the ratio of the Total Labor Force (in %) in Least developed countries in 2003 to that in 2006?
Offer a terse response. 1.01. What is the ratio of the Total Labor Force (in %) of North America in 2003 to that in 2006?
Give a very brief answer. 1.02. What is the ratio of the Total Labor Force (in %) of Guyana in 2003 to that in 2006?
Your answer should be very brief. 1. What is the ratio of the Total Labor Force (in %) in European Union in 2003 to that in 2007?
Provide a short and direct response. 0.97. What is the ratio of the Total Labor Force (in %) in Least developed countries in 2003 to that in 2007?
Offer a terse response. 1.01. What is the ratio of the Total Labor Force (in %) in North America in 2003 to that in 2007?
Ensure brevity in your answer.  1.03. What is the ratio of the Total Labor Force (in %) of Guyana in 2003 to that in 2007?
Make the answer very short. 1. What is the ratio of the Total Labor Force (in %) of European Union in 2003 to that in 2008?
Make the answer very short. 0.97. What is the ratio of the Total Labor Force (in %) in Least developed countries in 2003 to that in 2008?
Make the answer very short. 1.01. What is the ratio of the Total Labor Force (in %) of North America in 2003 to that in 2008?
Keep it short and to the point. 1.04. What is the ratio of the Total Labor Force (in %) in Guyana in 2003 to that in 2008?
Your answer should be very brief. 0.99. What is the ratio of the Total Labor Force (in %) of European Union in 2004 to that in 2005?
Your response must be concise. 1. What is the ratio of the Total Labor Force (in %) of Guyana in 2004 to that in 2005?
Your answer should be very brief. 1. What is the ratio of the Total Labor Force (in %) of European Union in 2004 to that in 2006?
Your answer should be very brief. 0.98. What is the ratio of the Total Labor Force (in %) of North America in 2004 to that in 2006?
Your response must be concise. 1.01. What is the ratio of the Total Labor Force (in %) of European Union in 2004 to that in 2007?
Provide a short and direct response. 0.98. What is the ratio of the Total Labor Force (in %) of Least developed countries in 2004 to that in 2007?
Offer a very short reply. 1.01. What is the ratio of the Total Labor Force (in %) of North America in 2004 to that in 2007?
Keep it short and to the point. 1.02. What is the ratio of the Total Labor Force (in %) of European Union in 2004 to that in 2008?
Offer a terse response. 0.98. What is the ratio of the Total Labor Force (in %) in North America in 2004 to that in 2008?
Provide a short and direct response. 1.03. What is the ratio of the Total Labor Force (in %) of Guyana in 2004 to that in 2008?
Keep it short and to the point. 0.99. What is the ratio of the Total Labor Force (in %) in European Union in 2005 to that in 2006?
Make the answer very short. 0.99. What is the ratio of the Total Labor Force (in %) of Least developed countries in 2005 to that in 2006?
Provide a short and direct response. 1. What is the ratio of the Total Labor Force (in %) of North America in 2005 to that in 2006?
Provide a succinct answer. 1.01. What is the ratio of the Total Labor Force (in %) in European Union in 2005 to that in 2007?
Provide a succinct answer. 0.99. What is the ratio of the Total Labor Force (in %) of Least developed countries in 2005 to that in 2007?
Make the answer very short. 1.01. What is the ratio of the Total Labor Force (in %) of North America in 2005 to that in 2007?
Make the answer very short. 1.02. What is the ratio of the Total Labor Force (in %) in Guyana in 2005 to that in 2007?
Make the answer very short. 1. What is the ratio of the Total Labor Force (in %) in European Union in 2005 to that in 2008?
Offer a terse response. 0.98. What is the ratio of the Total Labor Force (in %) of European Union in 2006 to that in 2007?
Give a very brief answer. 1. What is the ratio of the Total Labor Force (in %) of Least developed countries in 2006 to that in 2007?
Provide a short and direct response. 1. What is the ratio of the Total Labor Force (in %) of North America in 2006 to that in 2007?
Ensure brevity in your answer.  1.01. What is the ratio of the Total Labor Force (in %) in Guyana in 2006 to that in 2007?
Keep it short and to the point. 1. What is the ratio of the Total Labor Force (in %) in European Union in 2006 to that in 2008?
Give a very brief answer. 1. What is the ratio of the Total Labor Force (in %) of North America in 2006 to that in 2008?
Offer a very short reply. 1.02. What is the ratio of the Total Labor Force (in %) of Guyana in 2006 to that in 2008?
Give a very brief answer. 1. What is the ratio of the Total Labor Force (in %) in European Union in 2007 to that in 2008?
Provide a succinct answer. 1. What is the ratio of the Total Labor Force (in %) of North America in 2007 to that in 2008?
Provide a short and direct response. 1.01. What is the difference between the highest and the second highest Total Labor Force (in %) of European Union?
Make the answer very short. 0.15. What is the difference between the highest and the second highest Total Labor Force (in %) in North America?
Make the answer very short. 0.99. What is the difference between the highest and the lowest Total Labor Force (in %) in European Union?
Offer a terse response. 1.46. What is the difference between the highest and the lowest Total Labor Force (in %) in Least developed countries?
Provide a succinct answer. 0.63. What is the difference between the highest and the lowest Total Labor Force (in %) of North America?
Keep it short and to the point. 4.6. 